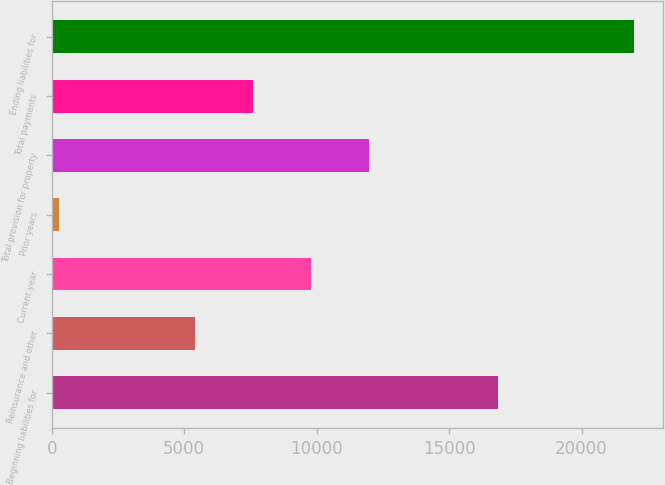Convert chart. <chart><loc_0><loc_0><loc_500><loc_500><bar_chart><fcel>Beginning liabilities for<fcel>Reinsurance and other<fcel>Current year<fcel>Prior years<fcel>Total provision for property<fcel>Total payments<fcel>Ending liabilities for<nl><fcel>16863<fcel>5403<fcel>9797<fcel>296<fcel>11994<fcel>7600<fcel>21991<nl></chart> 